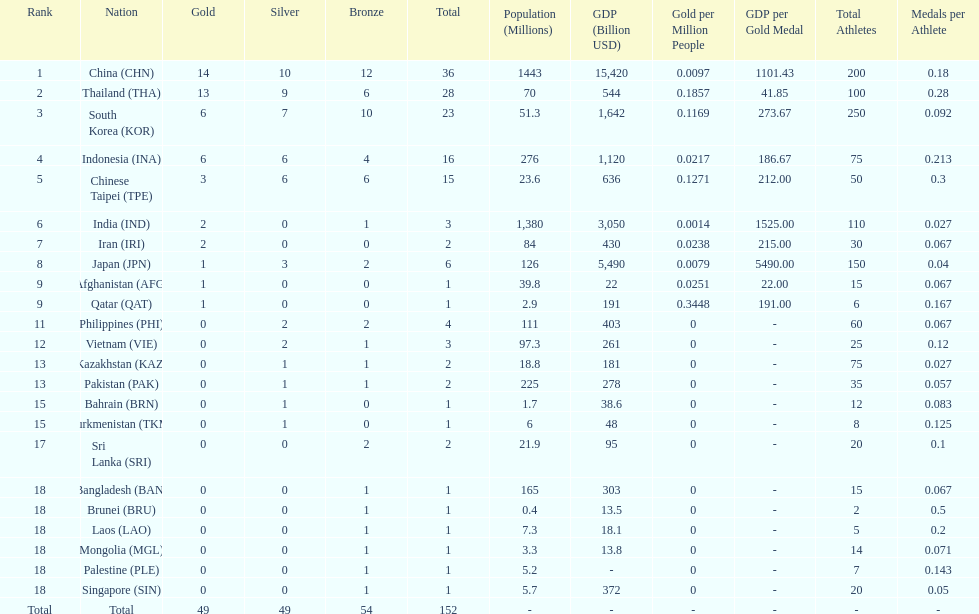Parse the full table. {'header': ['Rank', 'Nation', 'Gold', 'Silver', 'Bronze', 'Total', 'Population (Millions)', 'GDP (Billion USD)', 'Gold per Million People', 'GDP per Gold Medal', 'Total Athletes', 'Medals per Athlete'], 'rows': [['1', 'China\xa0(CHN)', '14', '10', '12', '36', '1443', '15,420', '0.0097', '1101.43', '200', '0.18'], ['2', 'Thailand\xa0(THA)', '13', '9', '6', '28', '70', '544', '0.1857', '41.85', '100', '0.28'], ['3', 'South Korea\xa0(KOR)', '6', '7', '10', '23', '51.3', '1,642', '0.1169', '273.67', '250', '0.092'], ['4', 'Indonesia\xa0(INA)', '6', '6', '4', '16', '276', '1,120', '0.0217', '186.67', '75', '0.213'], ['5', 'Chinese Taipei\xa0(TPE)', '3', '6', '6', '15', '23.6', '636', '0.1271', '212.00', '50', '0.3'], ['6', 'India\xa0(IND)', '2', '0', '1', '3', '1,380', '3,050', '0.0014', '1525.00', '110', '0.027'], ['7', 'Iran\xa0(IRI)', '2', '0', '0', '2', '84', '430', '0.0238', '215.00', '30', '0.067'], ['8', 'Japan\xa0(JPN)', '1', '3', '2', '6', '126', '5,490', '0.0079', '5490.00', '150', '0.04'], ['9', 'Afghanistan\xa0(AFG)', '1', '0', '0', '1', '39.8', '22', '0.0251', '22.00', '15', '0.067'], ['9', 'Qatar\xa0(QAT)', '1', '0', '0', '1', '2.9', '191', '0.3448', '191.00', '6', '0.167'], ['11', 'Philippines\xa0(PHI)', '0', '2', '2', '4', '111', '403', '0', '-', '60', '0.067'], ['12', 'Vietnam\xa0(VIE)', '0', '2', '1', '3', '97.3', '261', '0', '-', '25', '0.12'], ['13', 'Kazakhstan\xa0(KAZ)', '0', '1', '1', '2', '18.8', '181', '0', '-', '75', '0.027'], ['13', 'Pakistan\xa0(PAK)', '0', '1', '1', '2', '225', '278', '0', '-', '35', '0.057'], ['15', 'Bahrain\xa0(BRN)', '0', '1', '0', '1', '1.7', '38.6', '0', '-', '12', '0.083'], ['15', 'Turkmenistan\xa0(TKM)', '0', '1', '0', '1', '6', '48', '0', '-', '8', '0.125'], ['17', 'Sri Lanka\xa0(SRI)', '0', '0', '2', '2', '21.9', '95', '0', '-', '20', '0.1'], ['18', 'Bangladesh\xa0(BAN)', '0', '0', '1', '1', '165', '303', '0', '-', '15', '0.067'], ['18', 'Brunei\xa0(BRU)', '0', '0', '1', '1', '0.4', '13.5', '0', '-', '2', '0.5'], ['18', 'Laos\xa0(LAO)', '0', '0', '1', '1', '7.3', '18.1', '0', '-', '5', '0.2'], ['18', 'Mongolia\xa0(MGL)', '0', '0', '1', '1', '3.3', '13.8', '0', '-', '14', '0.071'], ['18', 'Palestine\xa0(PLE)', '0', '0', '1', '1', '5.2', '-', '0', '-', '7', '0.143'], ['18', 'Singapore\xa0(SIN)', '0', '0', '1', '1', '5.7', '372', '0', '-', '20', '0.05'], ['Total', 'Total', '49', '49', '54', '152', '-', '-', '-', '-', '-', '-']]} Which countries won the same number of gold medals as japan? Afghanistan (AFG), Qatar (QAT). 